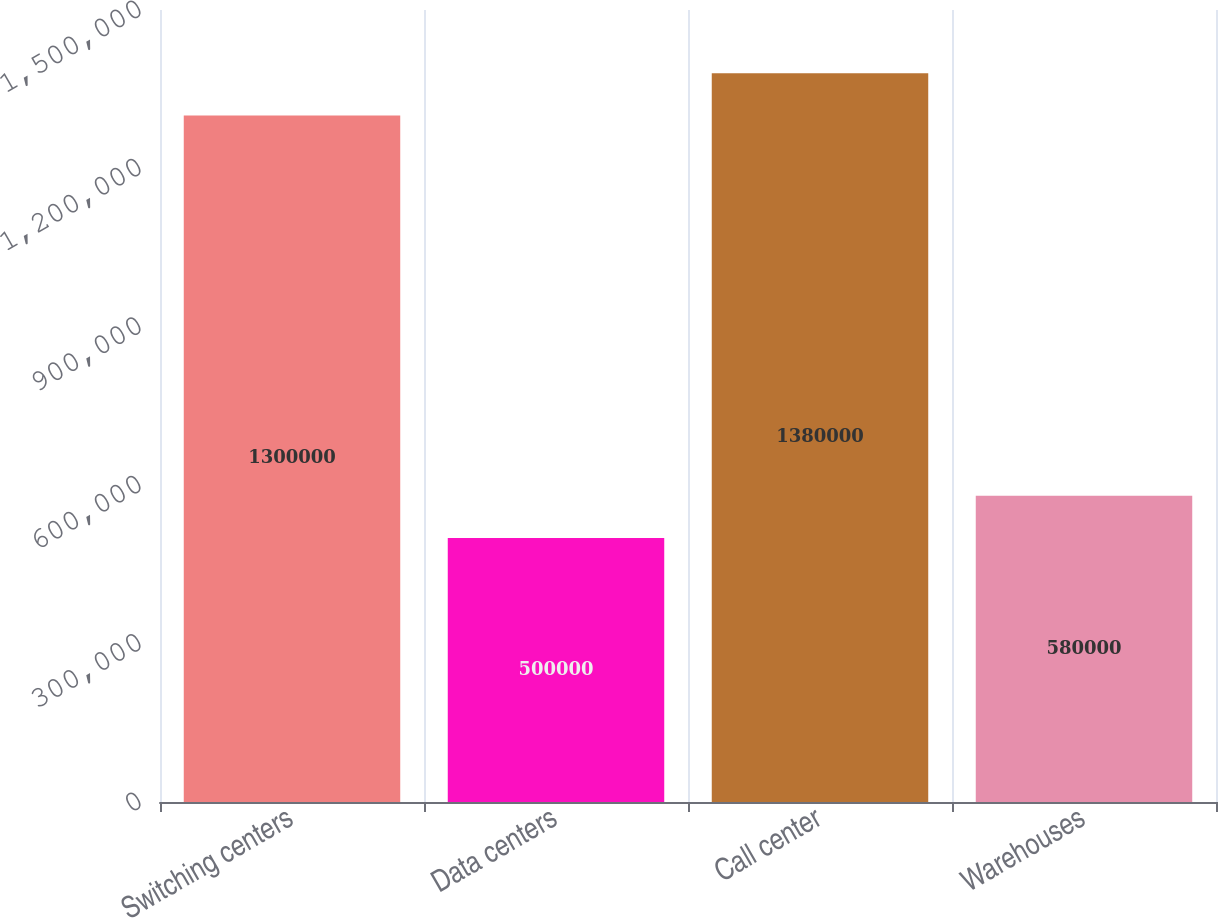Convert chart to OTSL. <chart><loc_0><loc_0><loc_500><loc_500><bar_chart><fcel>Switching centers<fcel>Data centers<fcel>Call center<fcel>Warehouses<nl><fcel>1.3e+06<fcel>500000<fcel>1.38e+06<fcel>580000<nl></chart> 